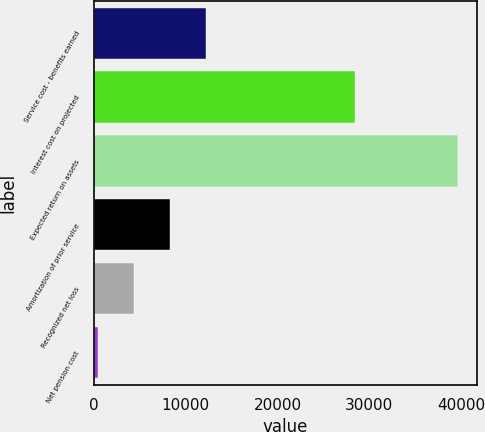Convert chart to OTSL. <chart><loc_0><loc_0><loc_500><loc_500><bar_chart><fcel>Service cost - benefits earned<fcel>Interest cost on projected<fcel>Expected return on assets<fcel>Amortization of prior service<fcel>Recognized net loss<fcel>Net pension cost<nl><fcel>12183.2<fcel>28471<fcel>39682<fcel>8254.8<fcel>4326.4<fcel>398<nl></chart> 